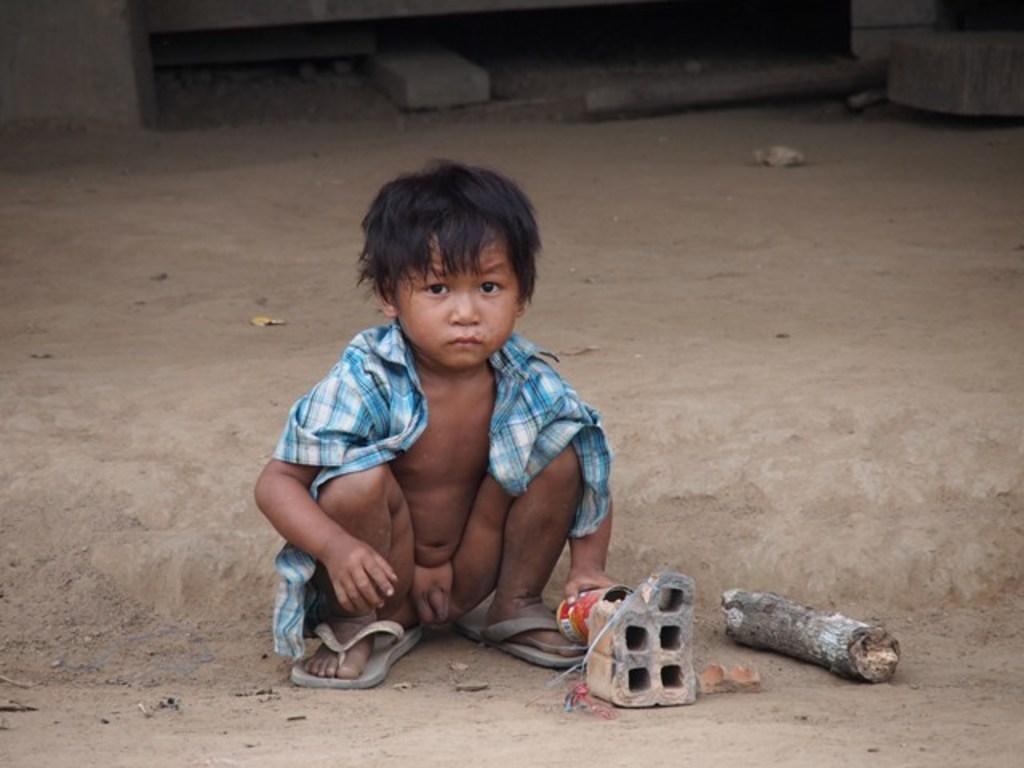Who is the main subject in the image? There is a boy in the image. What is the boy wearing? The boy is wearing a check shirt. What position is the boy in? The boy is in a crouch position. What is the boy holding in the image? The boy is holding a can. What can be seen on the ground in the image? There is a wood log on the ground. What else can be seen in the background of the image? There are other things visible in the background of the image. Can you see a duck wearing a veil in the image? No, there is no duck or veil present in the image. 